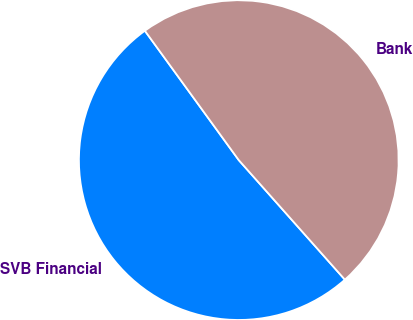<chart> <loc_0><loc_0><loc_500><loc_500><pie_chart><fcel>SVB Financial<fcel>Bank<nl><fcel>51.56%<fcel>48.44%<nl></chart> 